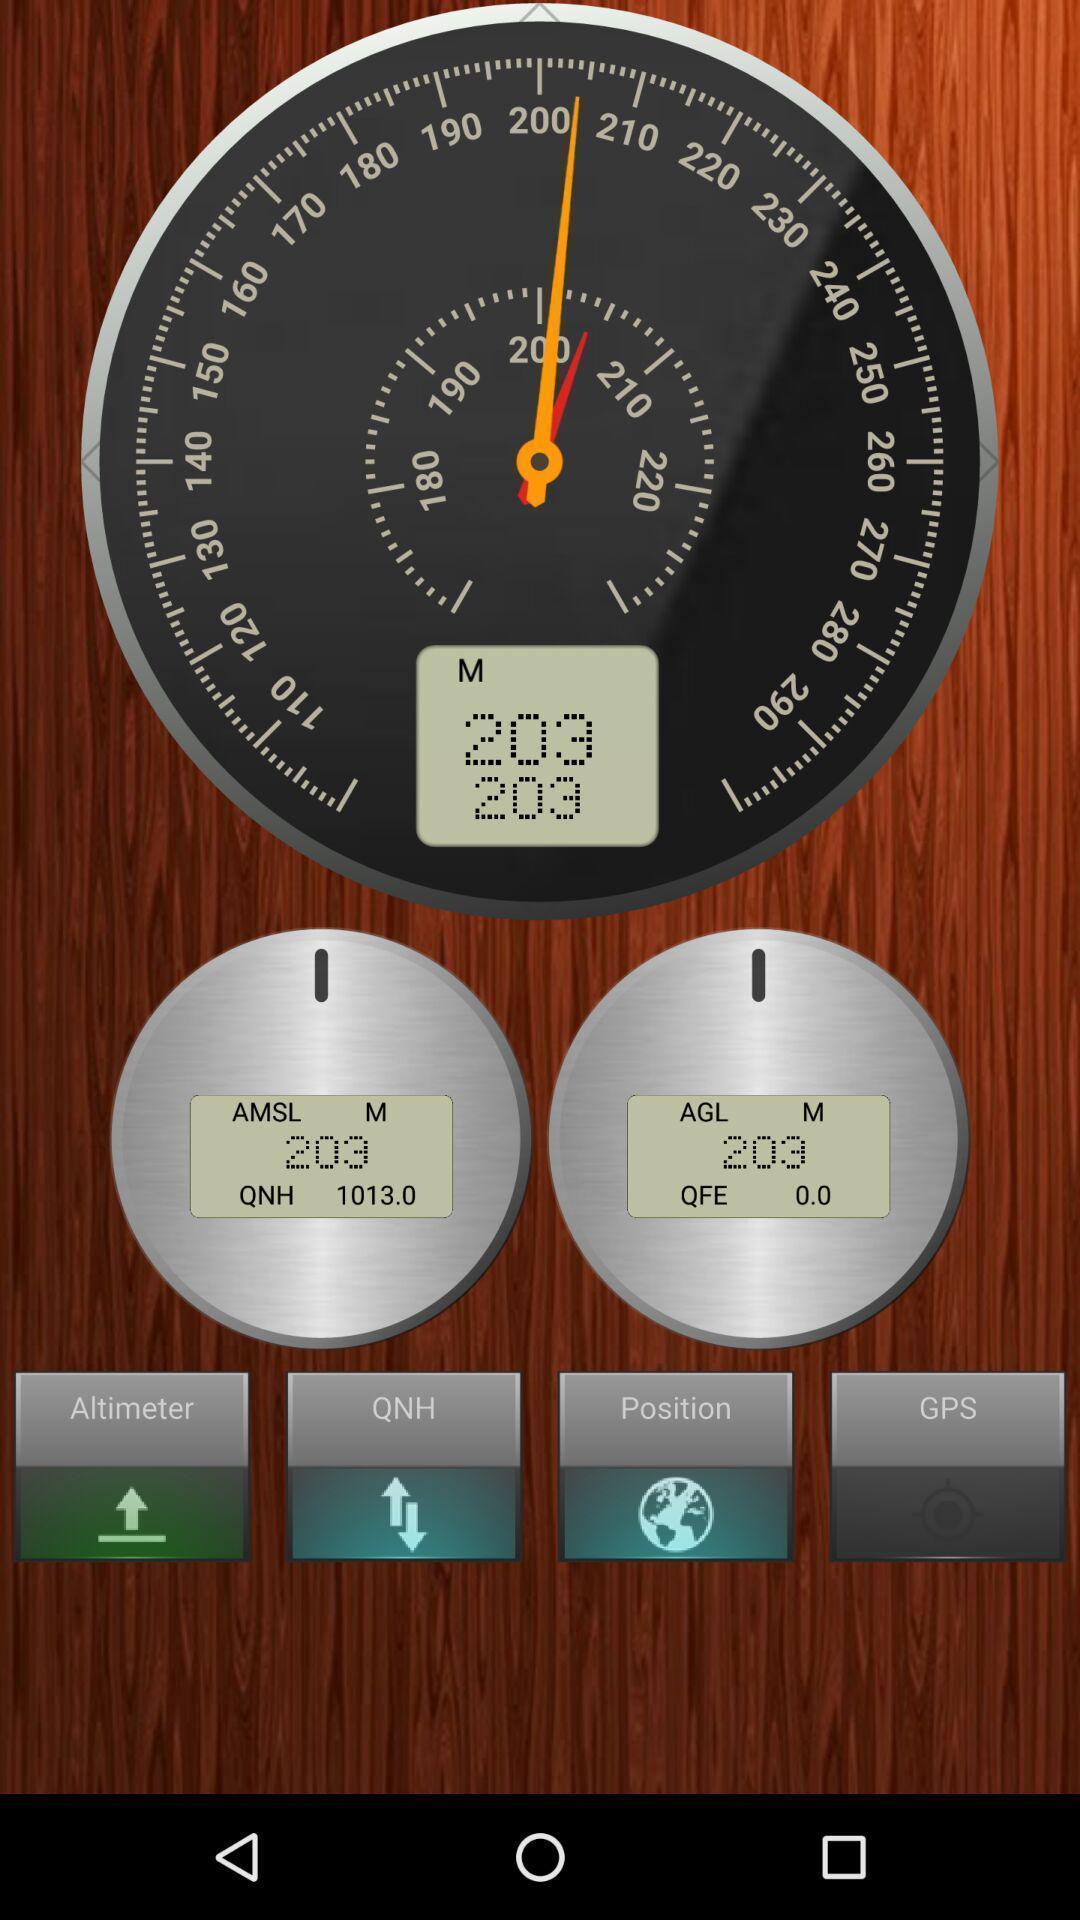Tell me about the visual elements in this screen capture. Page showing interface for a altitude measurement app. 